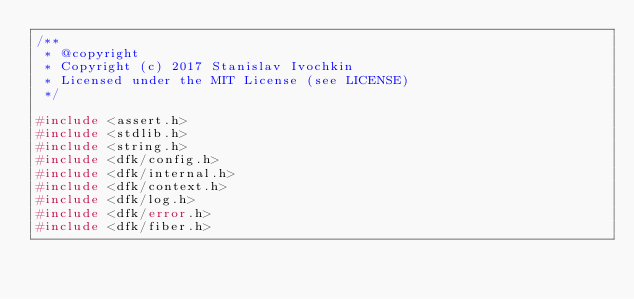Convert code to text. <code><loc_0><loc_0><loc_500><loc_500><_C_>/**
 * @copyright
 * Copyright (c) 2017 Stanislav Ivochkin
 * Licensed under the MIT License (see LICENSE)
 */

#include <assert.h>
#include <stdlib.h>
#include <string.h>
#include <dfk/config.h>
#include <dfk/internal.h>
#include <dfk/context.h>
#include <dfk/log.h>
#include <dfk/error.h>
#include <dfk/fiber.h></code> 